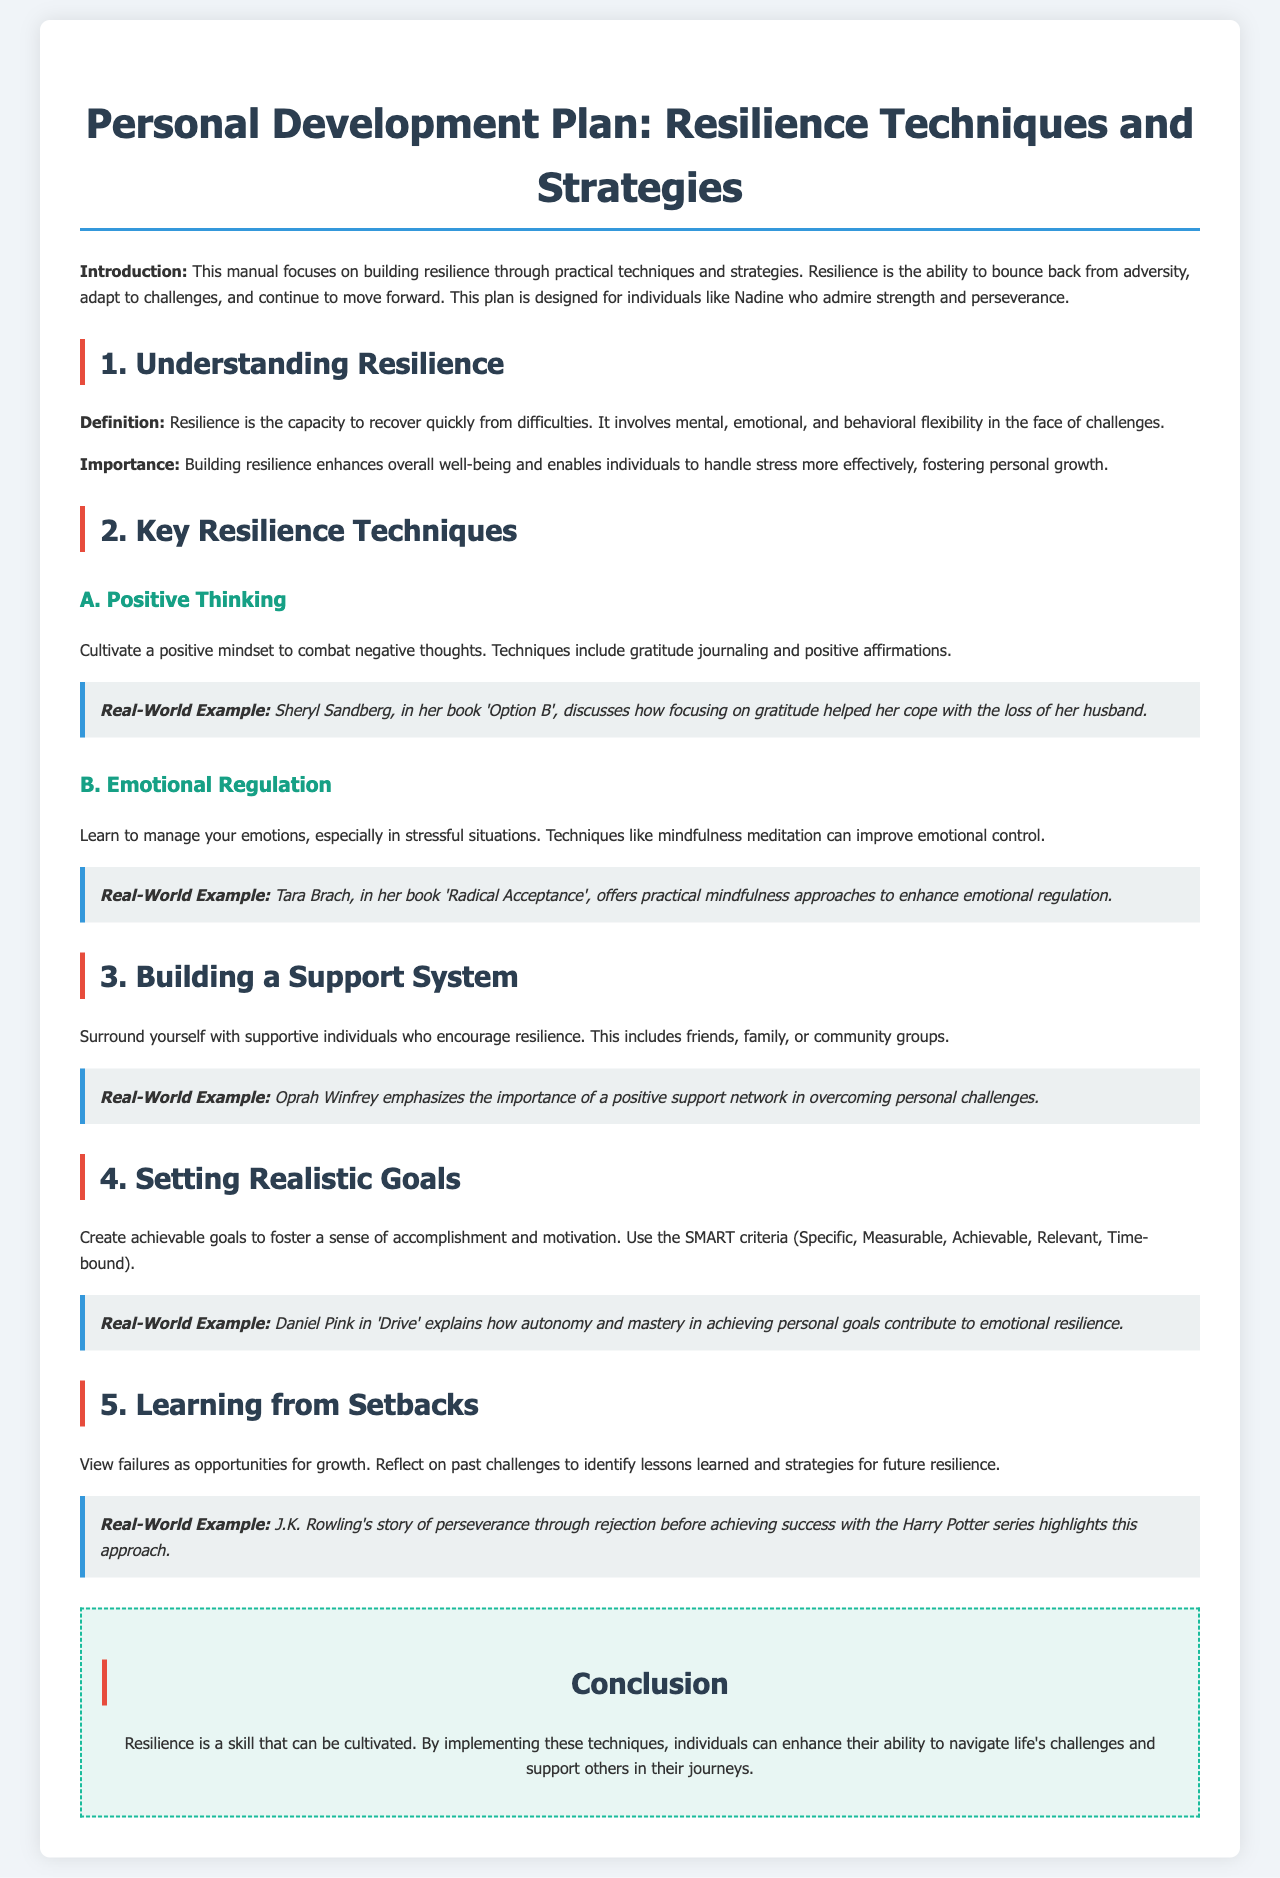What is the title of the document? The title of the document is found in the heading tag at the top of the page.
Answer: Personal Development Plan: Resilience Techniques and Strategies What does resilience enable individuals to do? This is stated in the importance section of resilience within the document.
Answer: Handle stress more effectively Who is mentioned to exemplify the importance of gratitude? The individual referenced in a real-world example in the positive thinking section.
Answer: Sheryl Sandberg What is the main technique for emotional regulation discussed? The primary technique mentioned for managing emotions in stressful situations.
Answer: Mindfulness meditation What criteria are suggested for setting realistic goals? The document outlines a specific acronym for achieving goals in the setting realistic goals section.
Answer: SMART criteria What is the purpose of building a support system? This is discussed in the section on building a support system and its role in resilience.
Answer: Encourage resilience What is one lesson learned from J.K. Rowling's story? This lesson elaborates on viewing failures in a positive light within the learning from setbacks section.
Answer: Perseverance through rejection 